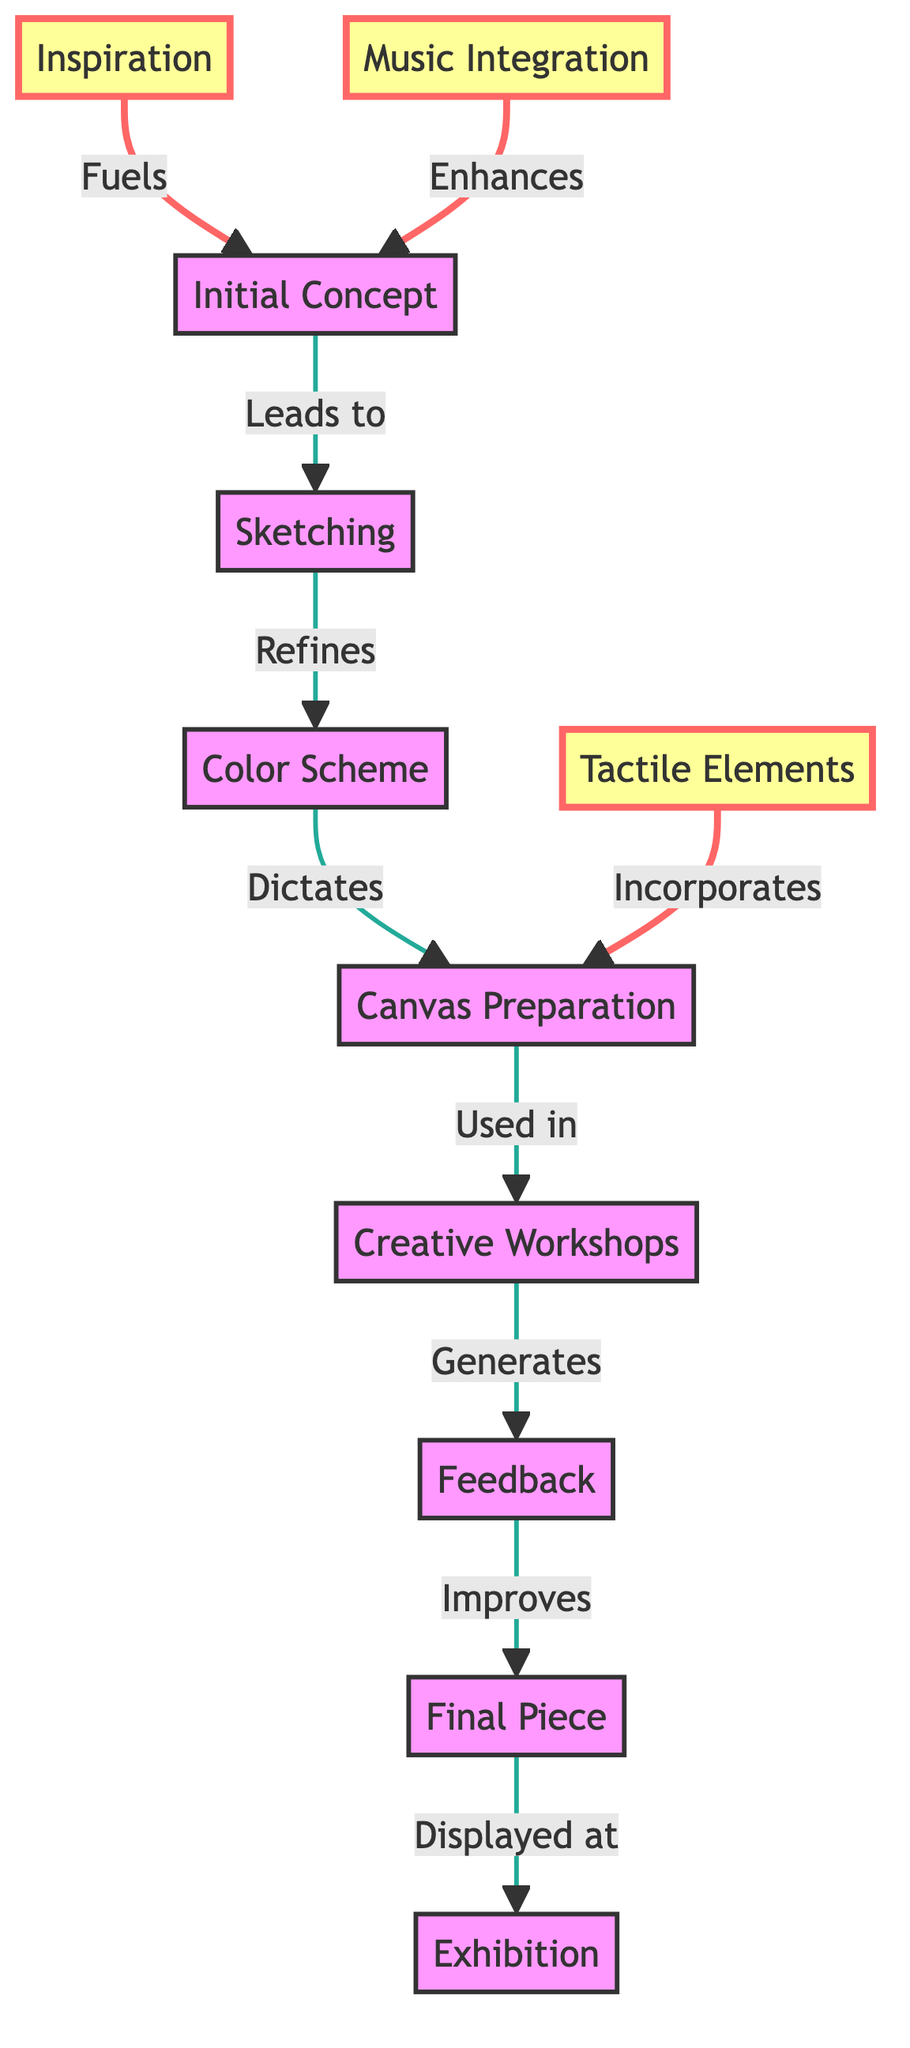What is the source that fuels the Initial Concept? According to the diagram, the Inspiration node is connected to the Initial Concept node with an edge labeled "Fuels." This means that Inspiration serves as the source that informs or energizes the initial theme or idea for the abstract project.
Answer: Inspiration How many nodes are represented in the diagram? The diagram includes nodes such as Inspiration, Music Integration, Tactile Elements, Initial Concept, Sketching, Color Scheme, Canvas Preparation, Creative Workshops, Feedback, Final Piece, and Exhibition. Counting these gives us a total of 11 nodes.
Answer: 11 What is the relationship between Color Scheme and Canvas Preparation? The diagram shows that Color Scheme has a directed edge leading to Canvas Preparation, labeled "Dictates." This indicates that the chosen Color Scheme influences or decides the preparation process for the canvas.
Answer: Dictates Which node generates Feedback? The Creative Workshops node is connected to the Feedback node with an edge labeled "Generates," indicating that it is during these collaborative sessions that feedback is produced.
Answer: Creative Workshops What is the final output displayed at an exhibition? The Final Piece node has a directed edge leading to the Exhibition node, labeled "Displayed at." This shows that the completed artwork (Final Piece) is what gets showcased in exhibitions.
Answer: Final Piece Which node incorporates Tactile Elements into the process? The Canvas Preparation node is linked to the Tactile Elements node with an edge labeled "Incorporates." This means that during the preparation of the canvas, tactile elements are included or used.
Answer: Canvas Preparation What step follows after the Sketching node? According to the diagram, the Sketching node leads directly to the Color Scheme node with an edge labeled "Refines." This means that after Sketching, the next step in the process is refining the color choices.
Answer: Color Scheme Which two nodes enhance the Initial Concept? The diagram shows that both Music Integration and Inspiration have edges directed toward the Initial Concept node. They are labeled "Enhances" and "Fuels," respectively, indicating that they both contribute to developing the initial idea.
Answer: Music Integration and Inspiration 